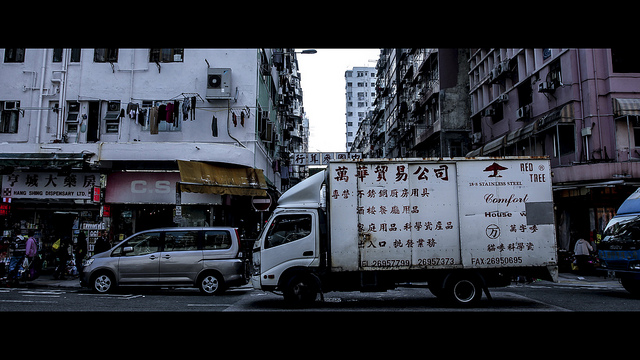Read and extract the text from this image. C S FAX 26950695 Comfort IN A STAIXUM STEALL TREE RED 26957373 26957799 